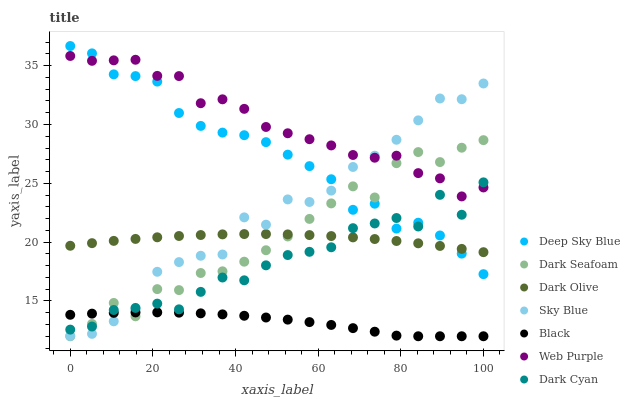Does Black have the minimum area under the curve?
Answer yes or no. Yes. Does Web Purple have the maximum area under the curve?
Answer yes or no. Yes. Does Dark Seafoam have the minimum area under the curve?
Answer yes or no. No. Does Dark Seafoam have the maximum area under the curve?
Answer yes or no. No. Is Dark Olive the smoothest?
Answer yes or no. Yes. Is Dark Seafoam the roughest?
Answer yes or no. Yes. Is Web Purple the smoothest?
Answer yes or no. No. Is Web Purple the roughest?
Answer yes or no. No. Does Dark Seafoam have the lowest value?
Answer yes or no. Yes. Does Web Purple have the lowest value?
Answer yes or no. No. Does Deep Sky Blue have the highest value?
Answer yes or no. Yes. Does Web Purple have the highest value?
Answer yes or no. No. Is Black less than Deep Sky Blue?
Answer yes or no. Yes. Is Web Purple greater than Dark Olive?
Answer yes or no. Yes. Does Sky Blue intersect Dark Cyan?
Answer yes or no. Yes. Is Sky Blue less than Dark Cyan?
Answer yes or no. No. Is Sky Blue greater than Dark Cyan?
Answer yes or no. No. Does Black intersect Deep Sky Blue?
Answer yes or no. No. 